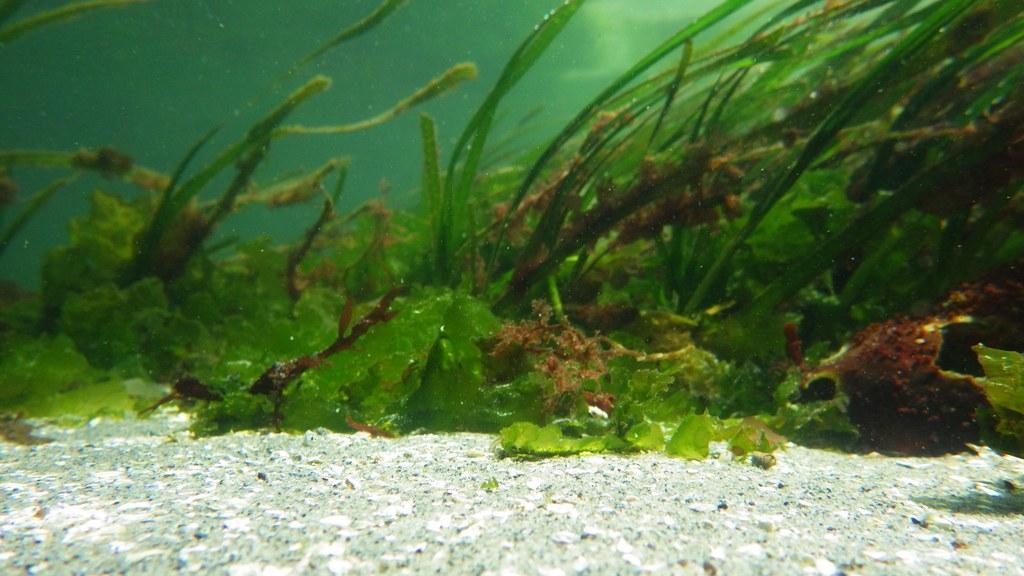In one or two sentences, can you explain what this image depicts? In this image we can see a view under the sea. 